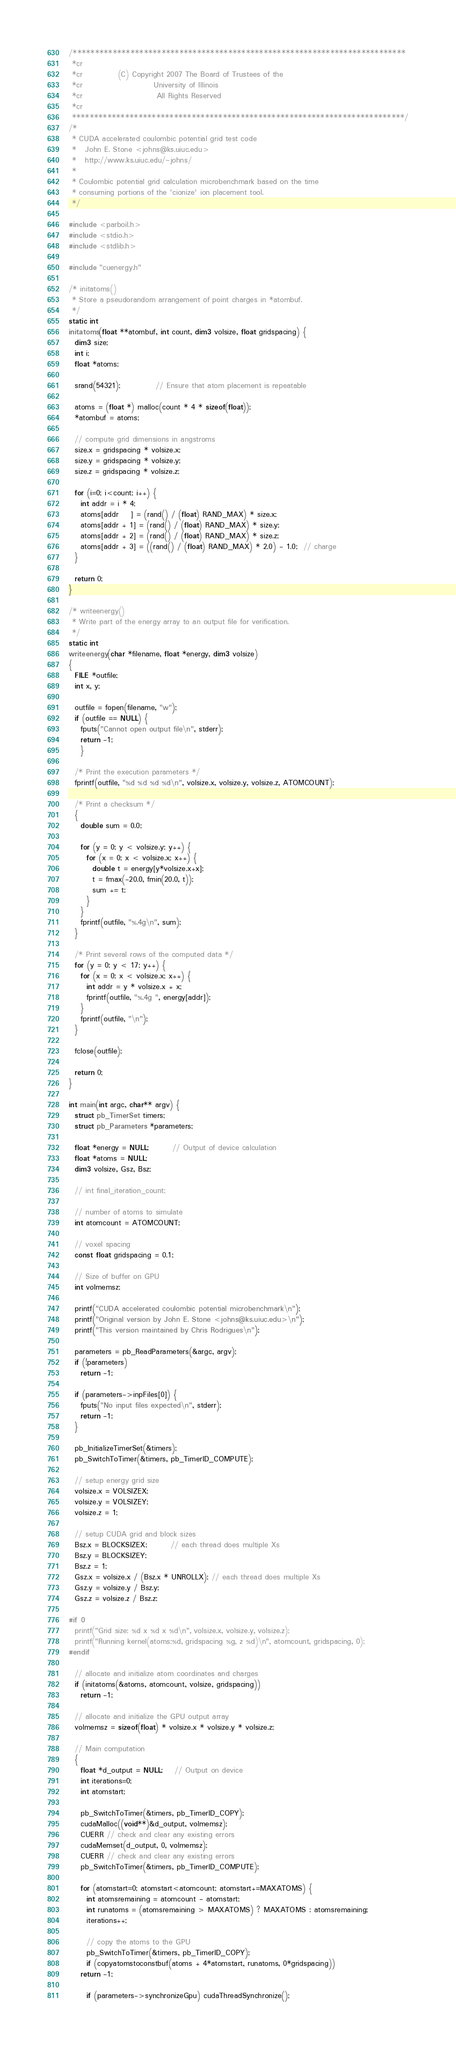<code> <loc_0><loc_0><loc_500><loc_500><_Cuda_>/***************************************************************************
 *cr
 *cr            (C) Copyright 2007 The Board of Trustees of the
 *cr                        University of Illinois
 *cr                         All Rights Reserved
 *cr
 ***************************************************************************/
/*
 * CUDA accelerated coulombic potential grid test code
 *   John E. Stone <johns@ks.uiuc.edu>
 *   http://www.ks.uiuc.edu/~johns/
 *
 * Coulombic potential grid calculation microbenchmark based on the time
 * consuming portions of the 'cionize' ion placement tool.
 */

#include <parboil.h>
#include <stdio.h>
#include <stdlib.h>

#include "cuenergy.h"

/* initatoms()
 * Store a pseudorandom arrangement of point charges in *atombuf.
 */
static int
initatoms(float **atombuf, int count, dim3 volsize, float gridspacing) {
  dim3 size;
  int i;
  float *atoms;

  srand(54321);			// Ensure that atom placement is repeatable

  atoms = (float *) malloc(count * 4 * sizeof(float));
  *atombuf = atoms;

  // compute grid dimensions in angstroms
  size.x = gridspacing * volsize.x;
  size.y = gridspacing * volsize.y;
  size.z = gridspacing * volsize.z;

  for (i=0; i<count; i++) {
    int addr = i * 4;
    atoms[addr    ] = (rand() / (float) RAND_MAX) * size.x; 
    atoms[addr + 1] = (rand() / (float) RAND_MAX) * size.y; 
    atoms[addr + 2] = (rand() / (float) RAND_MAX) * size.z; 
    atoms[addr + 3] = ((rand() / (float) RAND_MAX) * 2.0) - 1.0;  // charge
  }  

  return 0;
}

/* writeenergy()
 * Write part of the energy array to an output file for verification.
 */
static int
writeenergy(char *filename, float *energy, dim3 volsize)
{
  FILE *outfile;
  int x, y;

  outfile = fopen(filename, "w");
  if (outfile == NULL) {
    fputs("Cannot open output file\n", stderr);
    return -1;
    }

  /* Print the execution parameters */
  fprintf(outfile, "%d %d %d %d\n", volsize.x, volsize.y, volsize.z, ATOMCOUNT);

  /* Print a checksum */
  {
    double sum = 0.0;

    for (y = 0; y < volsize.y; y++) {
      for (x = 0; x < volsize.x; x++) {
        double t = energy[y*volsize.x+x];
        t = fmax(-20.0, fmin(20.0, t));
    	sum += t;
      }
    }
    fprintf(outfile, "%.4g\n", sum);
  }
  
  /* Print several rows of the computed data */
  for (y = 0; y < 17; y++) {
    for (x = 0; x < volsize.x; x++) {
      int addr = y * volsize.x + x;
      fprintf(outfile, "%.4g ", energy[addr]);
    }
    fprintf(outfile, "\n");
  }

  fclose(outfile);

  return 0;
}

int main(int argc, char** argv) {
  struct pb_TimerSet timers;
  struct pb_Parameters *parameters;

  float *energy = NULL;		// Output of device calculation
  float *atoms = NULL;
  dim3 volsize, Gsz, Bsz;

  // int final_iteration_count;

  // number of atoms to simulate
  int atomcount = ATOMCOUNT;

  // voxel spacing
  const float gridspacing = 0.1;

  // Size of buffer on GPU
  int volmemsz;

  printf("CUDA accelerated coulombic potential microbenchmark\n");
  printf("Original version by John E. Stone <johns@ks.uiuc.edu>\n");
  printf("This version maintained by Chris Rodrigues\n");

  parameters = pb_ReadParameters(&argc, argv);
  if (!parameters)
    return -1;

  if (parameters->inpFiles[0]) {
    fputs("No input files expected\n", stderr);
    return -1;
  }

  pb_InitializeTimerSet(&timers);
  pb_SwitchToTimer(&timers, pb_TimerID_COMPUTE);

  // setup energy grid size
  volsize.x = VOLSIZEX;
  volsize.y = VOLSIZEY;
  volsize.z = 1;

  // setup CUDA grid and block sizes
  Bsz.x = BLOCKSIZEX;		// each thread does multiple Xs
  Bsz.y = BLOCKSIZEY;
  Bsz.z = 1;
  Gsz.x = volsize.x / (Bsz.x * UNROLLX); // each thread does multiple Xs
  Gsz.y = volsize.y / Bsz.y; 
  Gsz.z = volsize.z / Bsz.z; 

#if 0
  printf("Grid size: %d x %d x %d\n", volsize.x, volsize.y, volsize.z);
  printf("Running kernel(atoms:%d, gridspacing %g, z %d)\n", atomcount, gridspacing, 0);
#endif

  // allocate and initialize atom coordinates and charges
  if (initatoms(&atoms, atomcount, volsize, gridspacing))
    return -1;

  // allocate and initialize the GPU output array
  volmemsz = sizeof(float) * volsize.x * volsize.y * volsize.z;

  // Main computation
  {
    float *d_output = NULL;	// Output on device
    int iterations=0;
    int atomstart;

    pb_SwitchToTimer(&timers, pb_TimerID_COPY);
    cudaMalloc((void**)&d_output, volmemsz);
    CUERR // check and clear any existing errors
    cudaMemset(d_output, 0, volmemsz);
    CUERR // check and clear any existing errors
    pb_SwitchToTimer(&timers, pb_TimerID_COMPUTE);

    for (atomstart=0; atomstart<atomcount; atomstart+=MAXATOMS) {   
      int atomsremaining = atomcount - atomstart;
      int runatoms = (atomsremaining > MAXATOMS) ? MAXATOMS : atomsremaining;
      iterations++;

      // copy the atoms to the GPU
      pb_SwitchToTimer(&timers, pb_TimerID_COPY);
      if (copyatomstoconstbuf(atoms + 4*atomstart, runatoms, 0*gridspacing)) 
	return -1;

      if (parameters->synchronizeGpu) cudaThreadSynchronize();</code> 